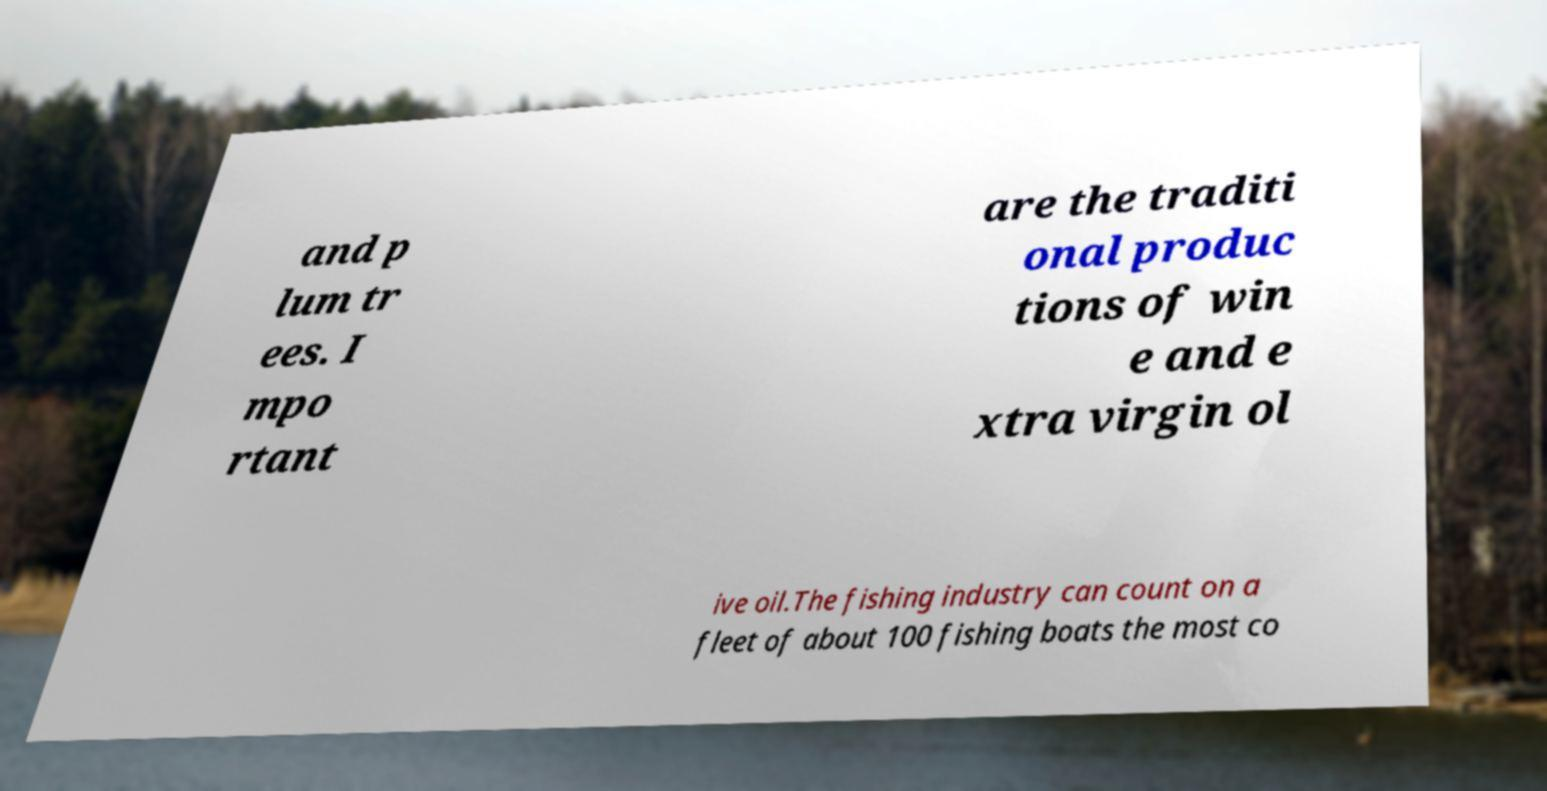Please read and relay the text visible in this image. What does it say? and p lum tr ees. I mpo rtant are the traditi onal produc tions of win e and e xtra virgin ol ive oil.The fishing industry can count on a fleet of about 100 fishing boats the most co 